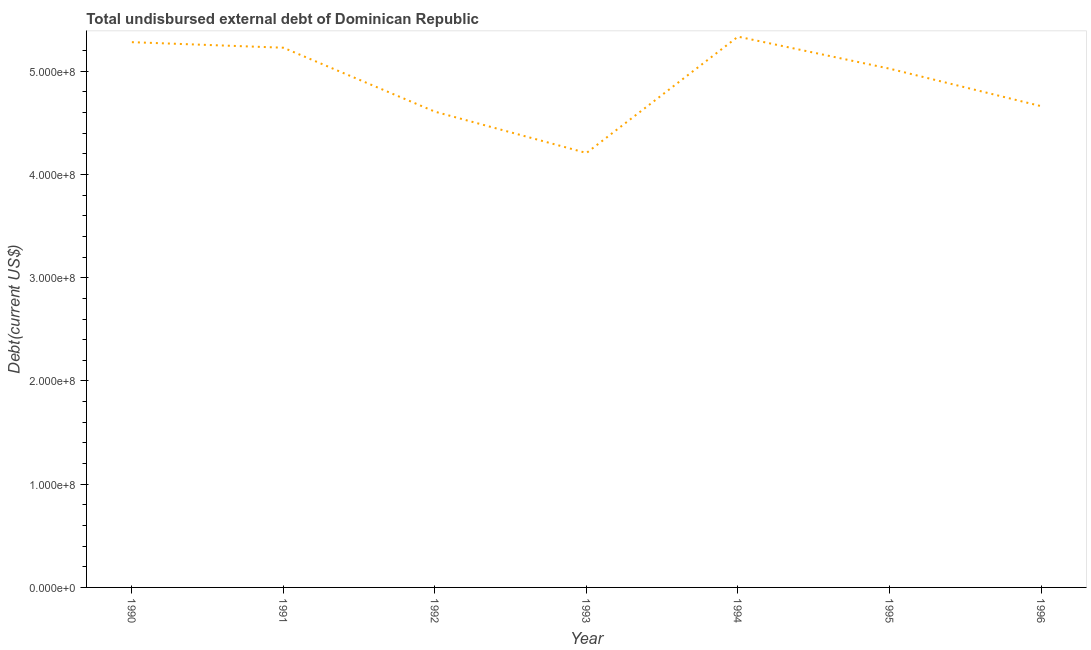What is the total debt in 1995?
Keep it short and to the point. 5.03e+08. Across all years, what is the maximum total debt?
Offer a terse response. 5.34e+08. Across all years, what is the minimum total debt?
Offer a very short reply. 4.21e+08. In which year was the total debt minimum?
Your answer should be very brief. 1993. What is the sum of the total debt?
Offer a very short reply. 3.44e+09. What is the difference between the total debt in 1990 and 1994?
Make the answer very short. -5.36e+06. What is the average total debt per year?
Provide a short and direct response. 4.91e+08. What is the median total debt?
Keep it short and to the point. 5.03e+08. In how many years, is the total debt greater than 340000000 US$?
Offer a terse response. 7. Do a majority of the years between 1996 and 1993 (inclusive) have total debt greater than 480000000 US$?
Offer a terse response. Yes. What is the ratio of the total debt in 1992 to that in 1995?
Make the answer very short. 0.92. What is the difference between the highest and the second highest total debt?
Offer a terse response. 5.36e+06. Is the sum of the total debt in 1992 and 1993 greater than the maximum total debt across all years?
Provide a short and direct response. Yes. What is the difference between the highest and the lowest total debt?
Give a very brief answer. 1.13e+08. In how many years, is the total debt greater than the average total debt taken over all years?
Your answer should be compact. 4. Does the total debt monotonically increase over the years?
Ensure brevity in your answer.  No. How many years are there in the graph?
Offer a terse response. 7. What is the title of the graph?
Offer a terse response. Total undisbursed external debt of Dominican Republic. What is the label or title of the Y-axis?
Your answer should be very brief. Debt(current US$). What is the Debt(current US$) in 1990?
Offer a very short reply. 5.28e+08. What is the Debt(current US$) of 1991?
Keep it short and to the point. 5.23e+08. What is the Debt(current US$) of 1992?
Provide a short and direct response. 4.61e+08. What is the Debt(current US$) of 1993?
Provide a succinct answer. 4.21e+08. What is the Debt(current US$) in 1994?
Keep it short and to the point. 5.34e+08. What is the Debt(current US$) of 1995?
Make the answer very short. 5.03e+08. What is the Debt(current US$) in 1996?
Offer a very short reply. 4.66e+08. What is the difference between the Debt(current US$) in 1990 and 1991?
Provide a succinct answer. 5.38e+06. What is the difference between the Debt(current US$) in 1990 and 1992?
Your response must be concise. 6.73e+07. What is the difference between the Debt(current US$) in 1990 and 1993?
Provide a short and direct response. 1.07e+08. What is the difference between the Debt(current US$) in 1990 and 1994?
Keep it short and to the point. -5.36e+06. What is the difference between the Debt(current US$) in 1990 and 1995?
Your response must be concise. 2.56e+07. What is the difference between the Debt(current US$) in 1990 and 1996?
Your response must be concise. 6.20e+07. What is the difference between the Debt(current US$) in 1991 and 1992?
Offer a terse response. 6.20e+07. What is the difference between the Debt(current US$) in 1991 and 1993?
Your response must be concise. 1.02e+08. What is the difference between the Debt(current US$) in 1991 and 1994?
Your answer should be very brief. -1.07e+07. What is the difference between the Debt(current US$) in 1991 and 1995?
Make the answer very short. 2.03e+07. What is the difference between the Debt(current US$) in 1991 and 1996?
Provide a succinct answer. 5.66e+07. What is the difference between the Debt(current US$) in 1992 and 1993?
Your answer should be compact. 4.00e+07. What is the difference between the Debt(current US$) in 1992 and 1994?
Offer a terse response. -7.27e+07. What is the difference between the Debt(current US$) in 1992 and 1995?
Provide a succinct answer. -4.17e+07. What is the difference between the Debt(current US$) in 1992 and 1996?
Your response must be concise. -5.35e+06. What is the difference between the Debt(current US$) in 1993 and 1994?
Your answer should be compact. -1.13e+08. What is the difference between the Debt(current US$) in 1993 and 1995?
Provide a succinct answer. -8.17e+07. What is the difference between the Debt(current US$) in 1993 and 1996?
Make the answer very short. -4.54e+07. What is the difference between the Debt(current US$) in 1994 and 1995?
Offer a very short reply. 3.10e+07. What is the difference between the Debt(current US$) in 1994 and 1996?
Provide a short and direct response. 6.73e+07. What is the difference between the Debt(current US$) in 1995 and 1996?
Provide a short and direct response. 3.63e+07. What is the ratio of the Debt(current US$) in 1990 to that in 1991?
Ensure brevity in your answer.  1.01. What is the ratio of the Debt(current US$) in 1990 to that in 1992?
Your response must be concise. 1.15. What is the ratio of the Debt(current US$) in 1990 to that in 1993?
Your answer should be very brief. 1.25. What is the ratio of the Debt(current US$) in 1990 to that in 1995?
Your answer should be compact. 1.05. What is the ratio of the Debt(current US$) in 1990 to that in 1996?
Your answer should be compact. 1.13. What is the ratio of the Debt(current US$) in 1991 to that in 1992?
Provide a short and direct response. 1.13. What is the ratio of the Debt(current US$) in 1991 to that in 1993?
Keep it short and to the point. 1.24. What is the ratio of the Debt(current US$) in 1991 to that in 1994?
Keep it short and to the point. 0.98. What is the ratio of the Debt(current US$) in 1991 to that in 1995?
Offer a very short reply. 1.04. What is the ratio of the Debt(current US$) in 1991 to that in 1996?
Ensure brevity in your answer.  1.12. What is the ratio of the Debt(current US$) in 1992 to that in 1993?
Ensure brevity in your answer.  1.09. What is the ratio of the Debt(current US$) in 1992 to that in 1994?
Your answer should be compact. 0.86. What is the ratio of the Debt(current US$) in 1992 to that in 1995?
Provide a short and direct response. 0.92. What is the ratio of the Debt(current US$) in 1993 to that in 1994?
Your answer should be very brief. 0.79. What is the ratio of the Debt(current US$) in 1993 to that in 1995?
Offer a very short reply. 0.84. What is the ratio of the Debt(current US$) in 1993 to that in 1996?
Provide a succinct answer. 0.9. What is the ratio of the Debt(current US$) in 1994 to that in 1995?
Ensure brevity in your answer.  1.06. What is the ratio of the Debt(current US$) in 1994 to that in 1996?
Ensure brevity in your answer.  1.14. What is the ratio of the Debt(current US$) in 1995 to that in 1996?
Give a very brief answer. 1.08. 